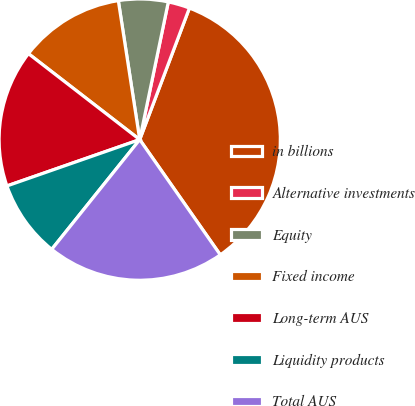Convert chart. <chart><loc_0><loc_0><loc_500><loc_500><pie_chart><fcel>in billions<fcel>Alternative investments<fcel>Equity<fcel>Fixed income<fcel>Long-term AUS<fcel>Liquidity products<fcel>Total AUS<nl><fcel>34.54%<fcel>2.49%<fcel>5.69%<fcel>12.1%<fcel>15.81%<fcel>8.9%<fcel>20.47%<nl></chart> 